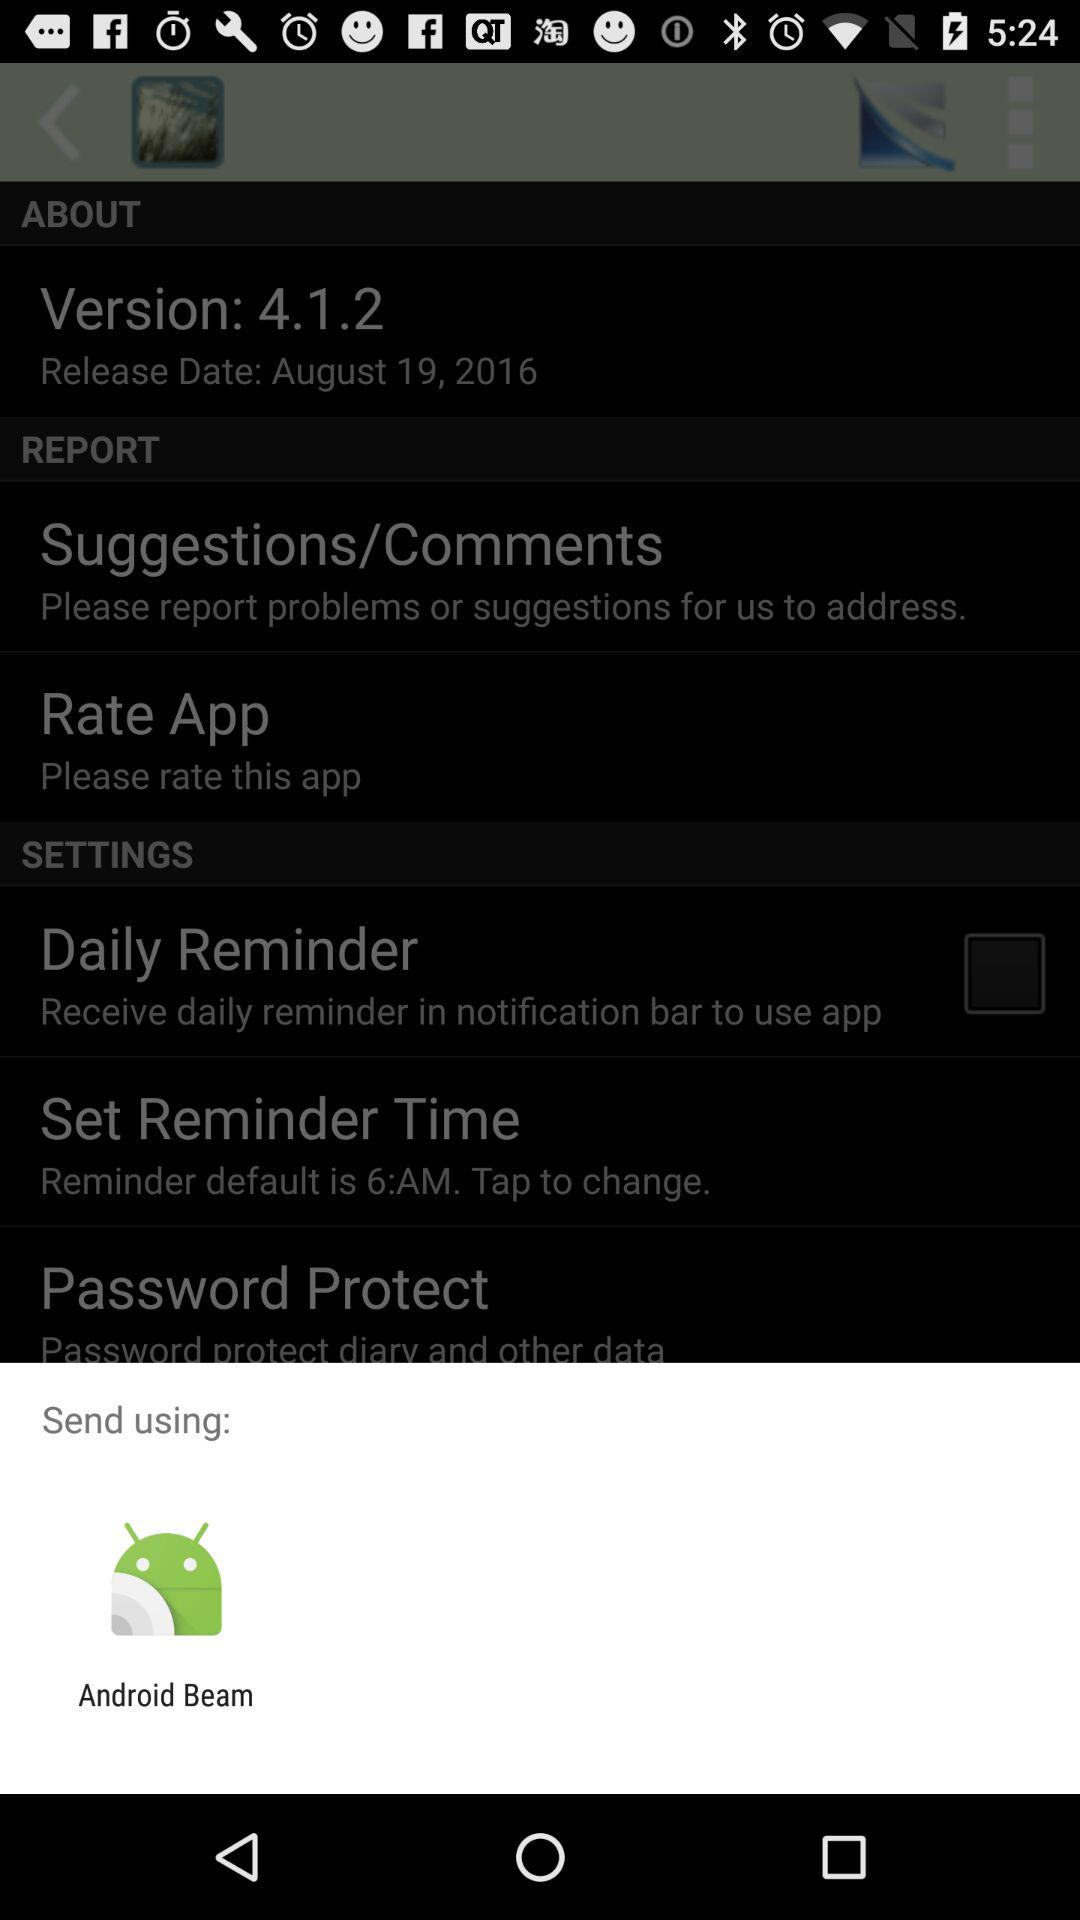What is the default time for the reminder? The default time for the reminder is 6 AM. 